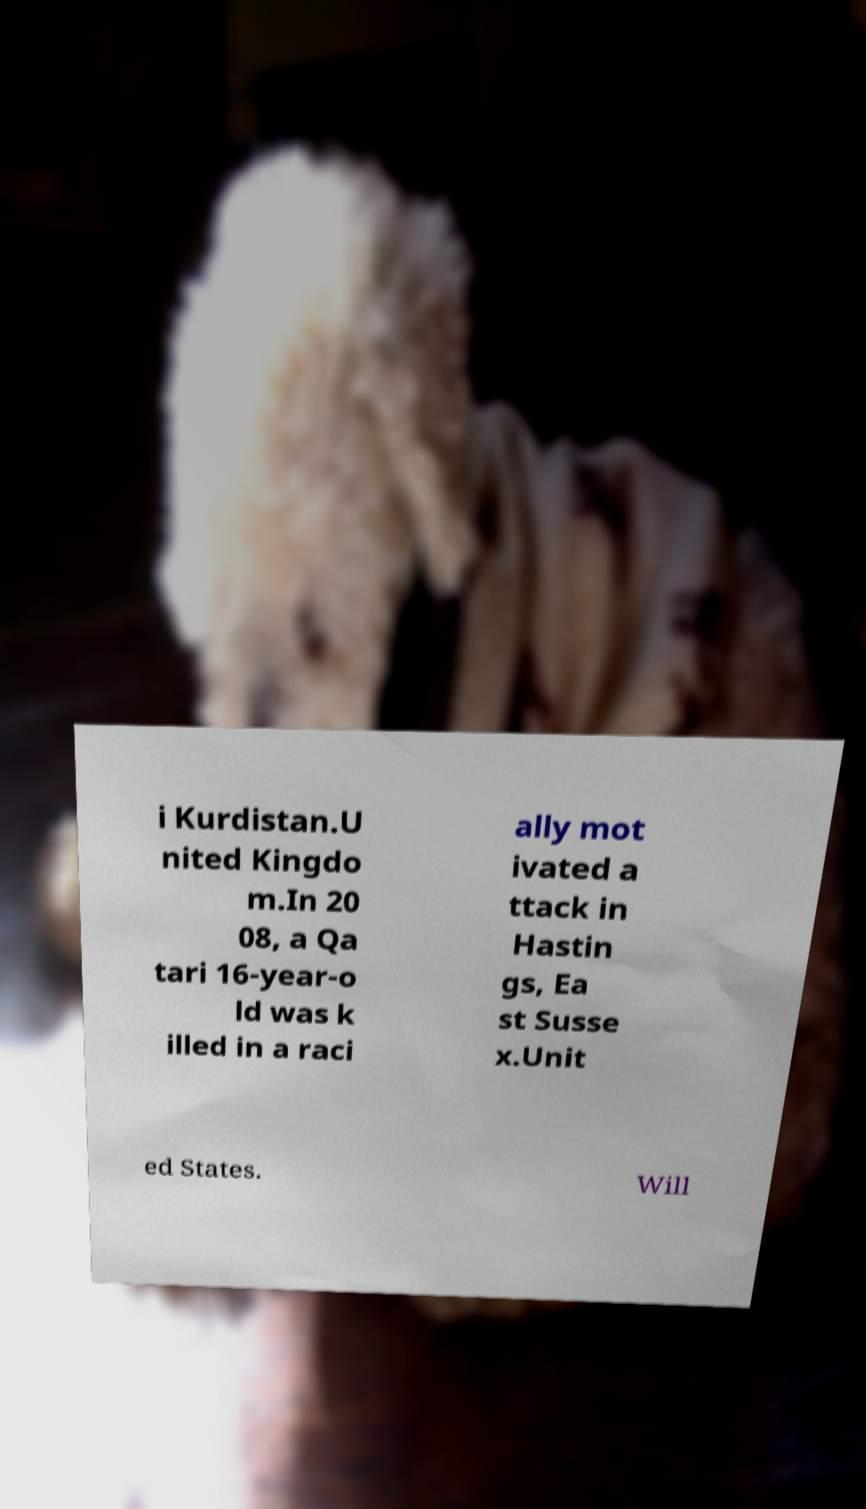Could you assist in decoding the text presented in this image and type it out clearly? i Kurdistan.U nited Kingdo m.In 20 08, a Qa tari 16-year-o ld was k illed in a raci ally mot ivated a ttack in Hastin gs, Ea st Susse x.Unit ed States. Will 